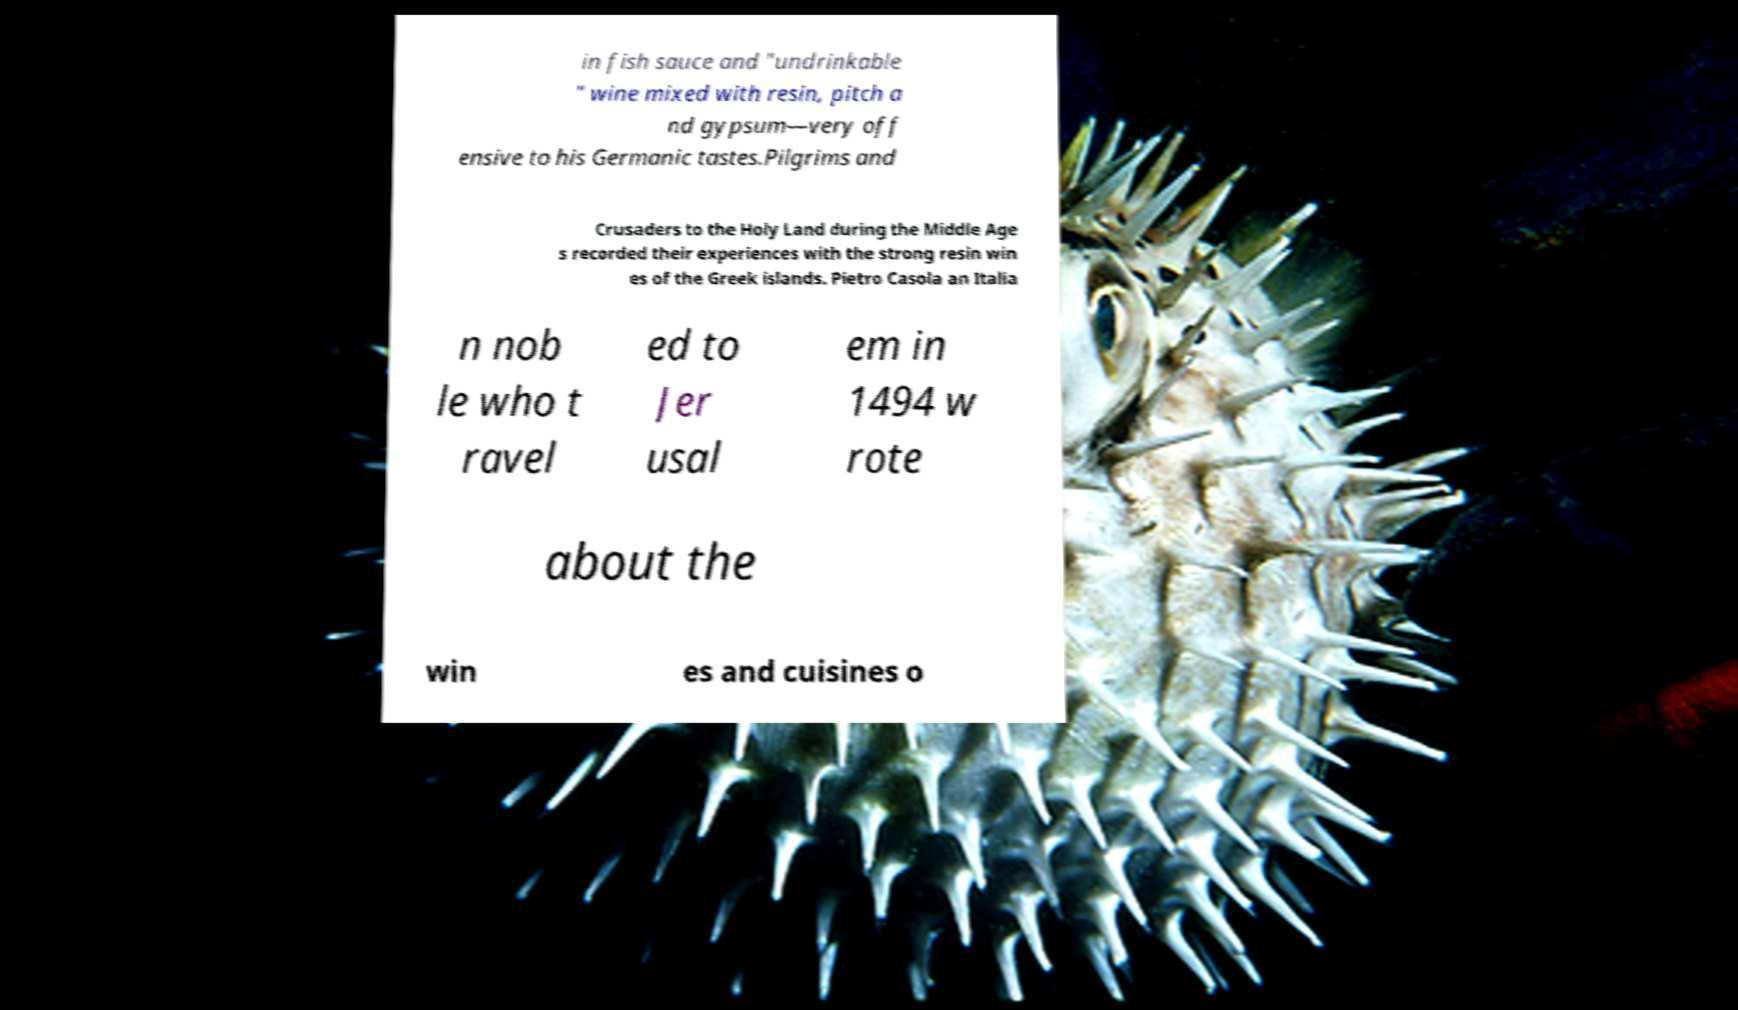For documentation purposes, I need the text within this image transcribed. Could you provide that? in fish sauce and "undrinkable " wine mixed with resin, pitch a nd gypsum—very off ensive to his Germanic tastes.Pilgrims and Crusaders to the Holy Land during the Middle Age s recorded their experiences with the strong resin win es of the Greek islands. Pietro Casola an Italia n nob le who t ravel ed to Jer usal em in 1494 w rote about the win es and cuisines o 